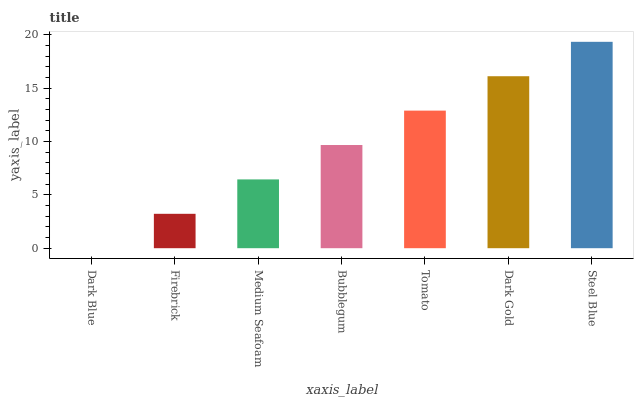Is Dark Blue the minimum?
Answer yes or no. Yes. Is Steel Blue the maximum?
Answer yes or no. Yes. Is Firebrick the minimum?
Answer yes or no. No. Is Firebrick the maximum?
Answer yes or no. No. Is Firebrick greater than Dark Blue?
Answer yes or no. Yes. Is Dark Blue less than Firebrick?
Answer yes or no. Yes. Is Dark Blue greater than Firebrick?
Answer yes or no. No. Is Firebrick less than Dark Blue?
Answer yes or no. No. Is Bubblegum the high median?
Answer yes or no. Yes. Is Bubblegum the low median?
Answer yes or no. Yes. Is Dark Blue the high median?
Answer yes or no. No. Is Dark Blue the low median?
Answer yes or no. No. 